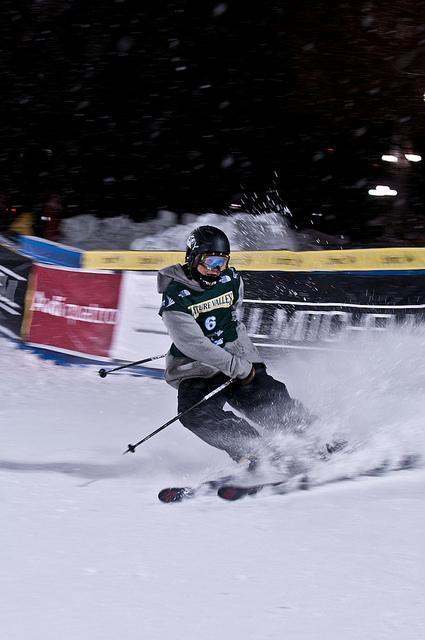How many vans follows the bus in a given image?
Give a very brief answer. 0. 